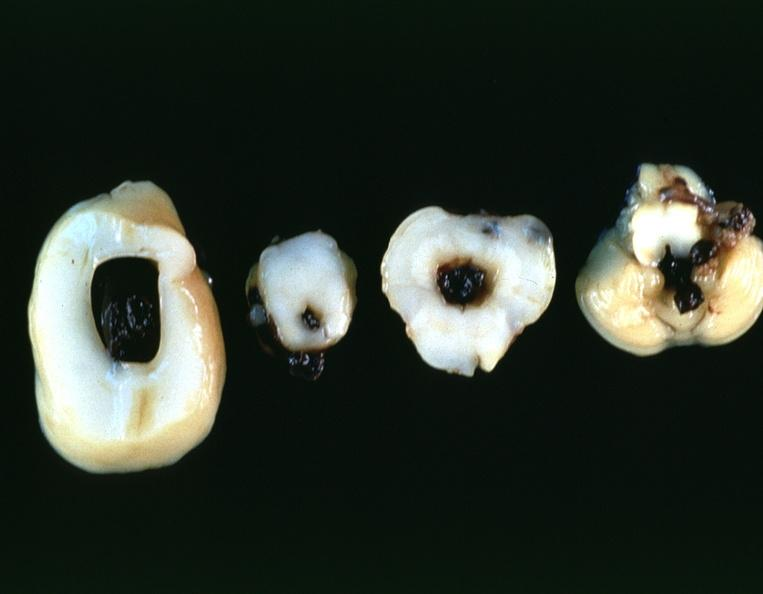what is present?
Answer the question using a single word or phrase. Nervous 